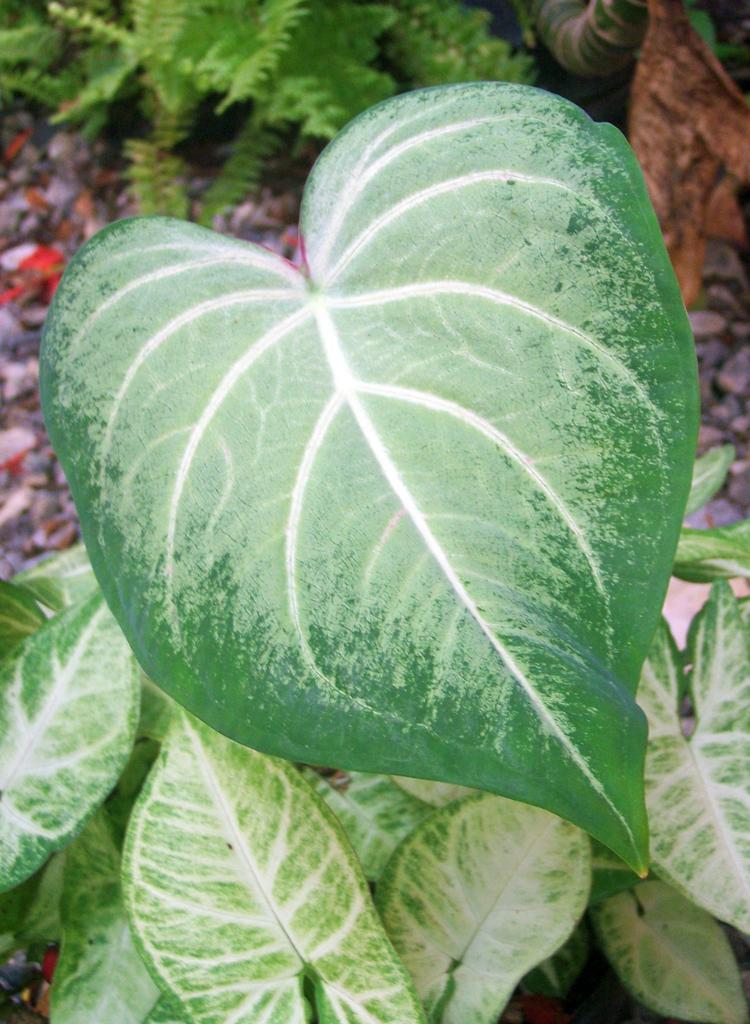Can you describe this image briefly? In the middle of the picture, we see a leaf which is green in color. At the bottom of the picture, we see a plant. At the top of the picture, we see a plant. In the background, we see small stones. 